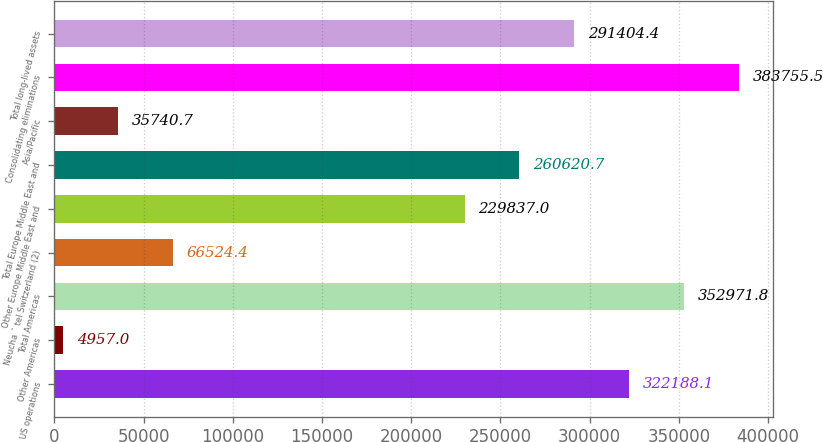Convert chart to OTSL. <chart><loc_0><loc_0><loc_500><loc_500><bar_chart><fcel>US operations<fcel>Other Americas<fcel>Total Americas<fcel>Neucha ˆ tel Switzerland (2)<fcel>Other Europe Middle East and<fcel>Total Europe Middle East and<fcel>Asia/Pacific<fcel>Consolidating eliminations<fcel>Total long-lived assets<nl><fcel>322188<fcel>4957<fcel>352972<fcel>66524.4<fcel>229837<fcel>260621<fcel>35740.7<fcel>383756<fcel>291404<nl></chart> 